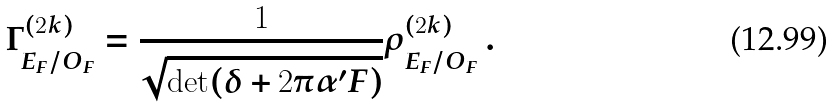<formula> <loc_0><loc_0><loc_500><loc_500>\Gamma ^ { ( 2 k ) } _ { E _ { F } / O _ { F } } = \frac { 1 } { \sqrt { \det ( \delta + 2 \pi \alpha ^ { \prime } F ) } } \rho ^ { ( 2 k ) } _ { E _ { F } / O _ { F } } \, .</formula> 